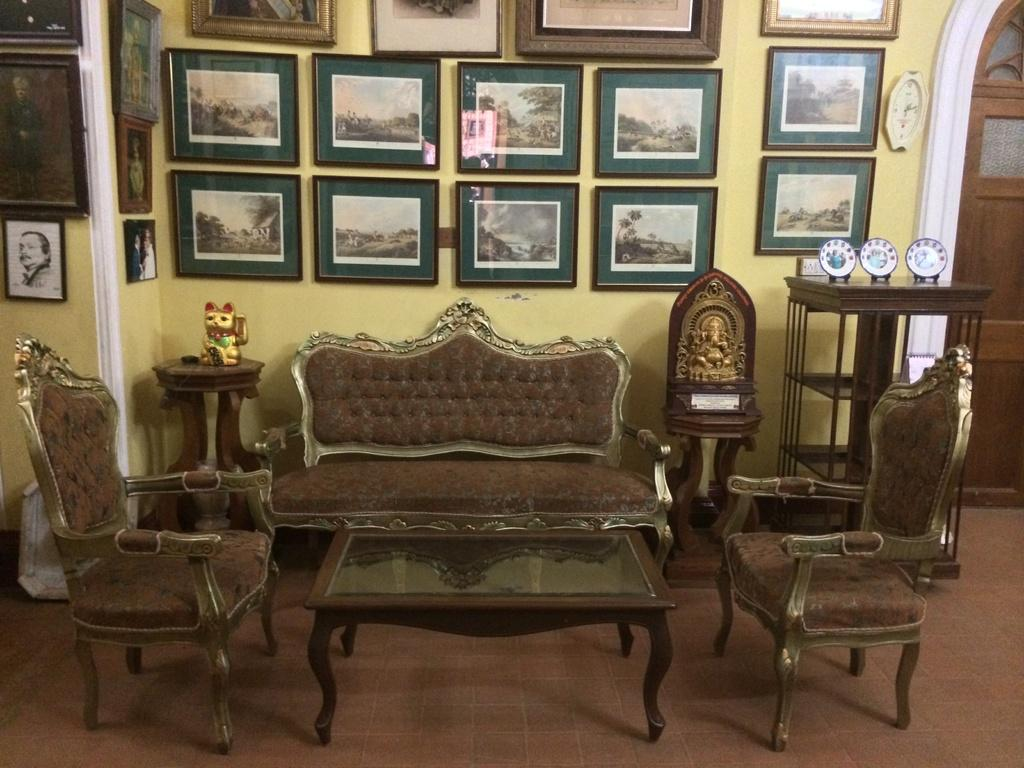Where is the setting of the image? The image is inside a room. What type of furniture is present in the room? There is a sofa set and a table in the room. What can be found on the floor in the room? There are statues on the floor in the room. What is attached to the wall in the room? There are photo frames attached to the wall in the room. Can you see a cat wearing a cap in the office setting of the image? There is no cat or office setting present in the image. The image is inside a room with a sofa set, table, statues, and photo frames. 